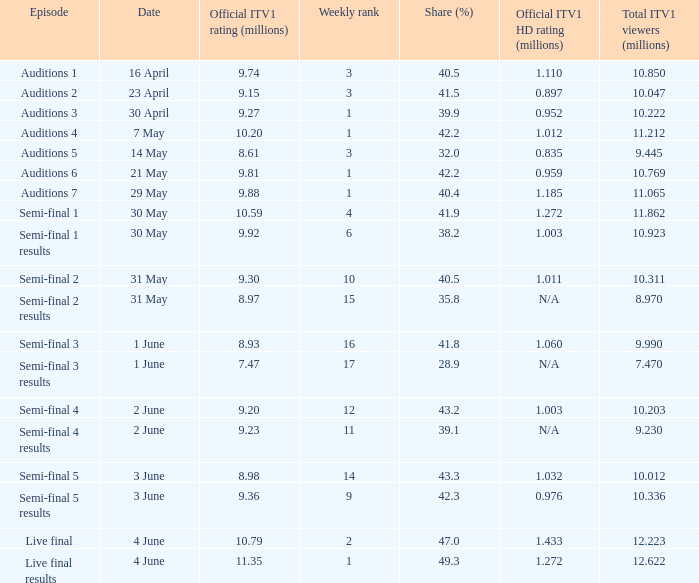When was the episode with a 4 23 April. 